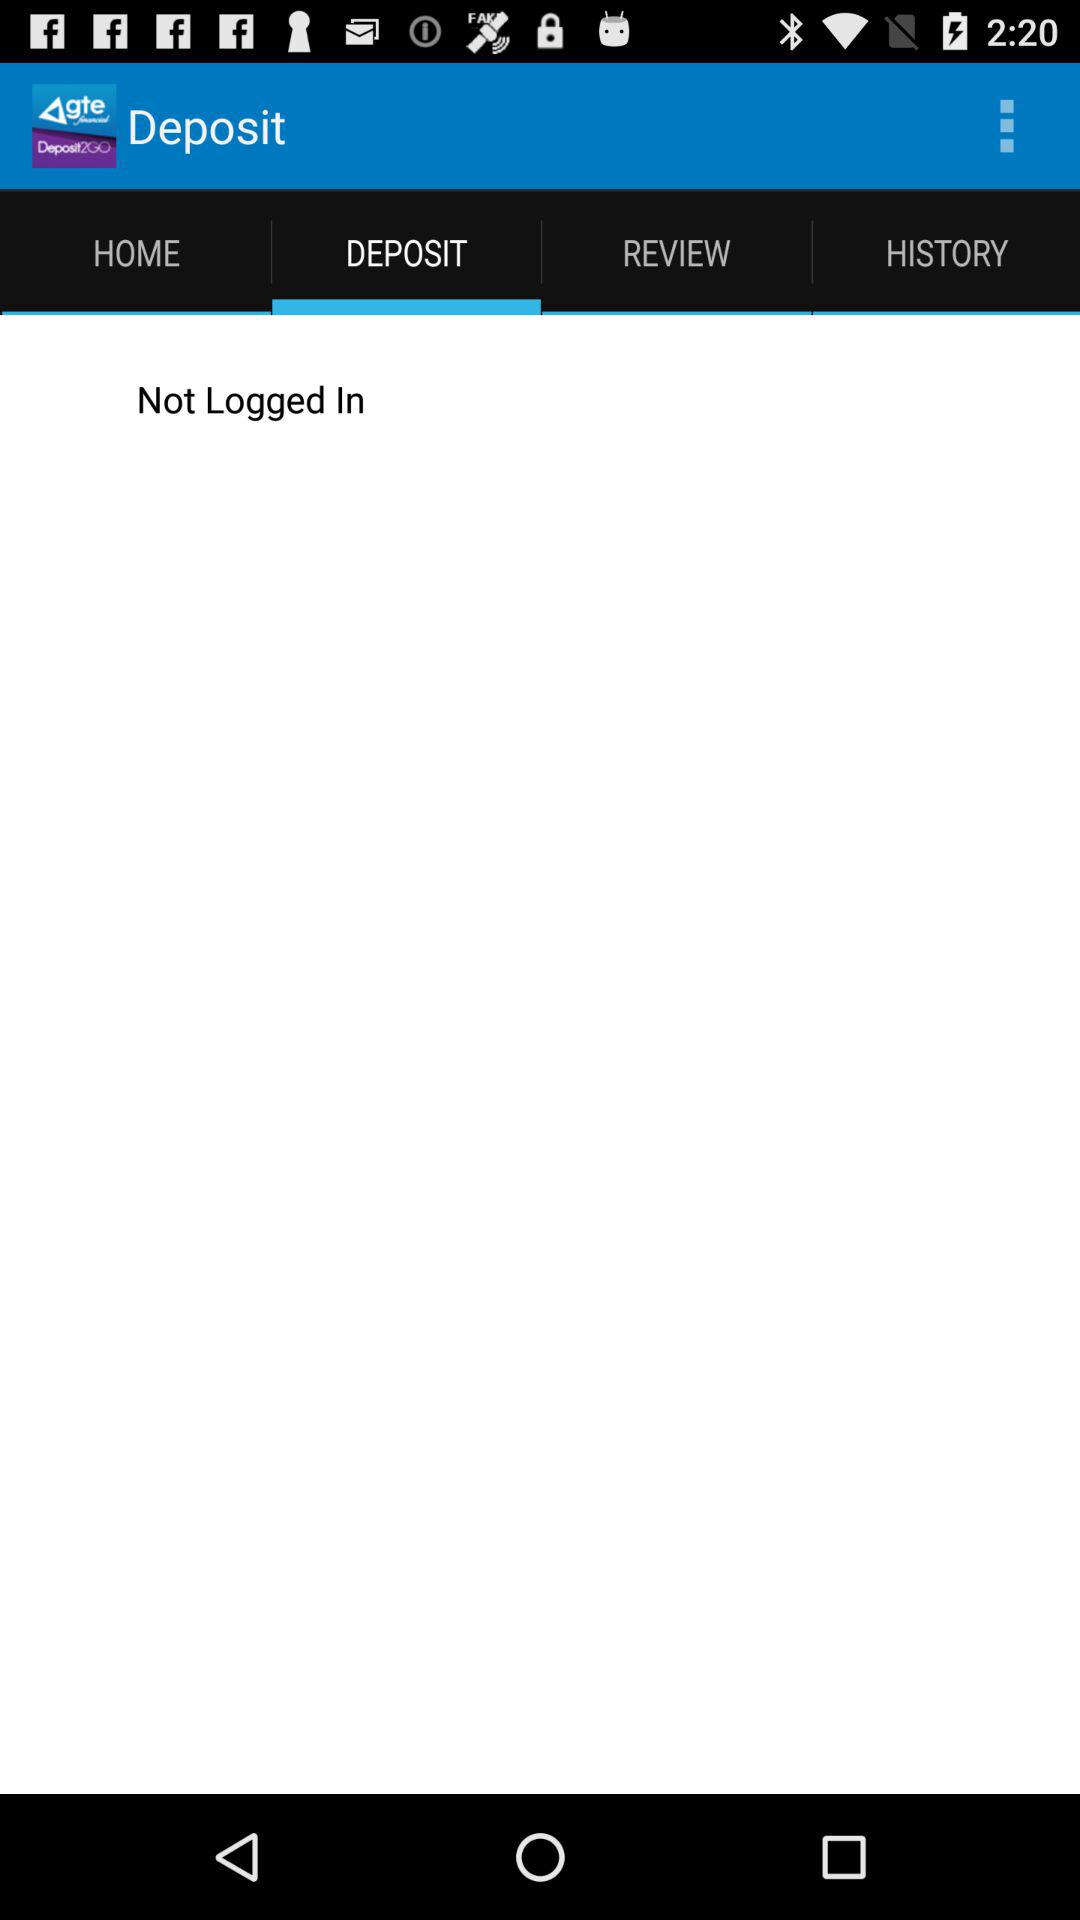What is the application name? The application name is " Deposit2GO". 